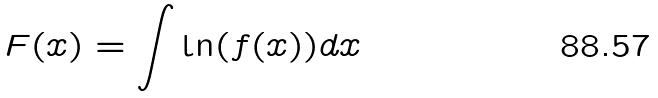Convert formula to latex. <formula><loc_0><loc_0><loc_500><loc_500>F ( x ) = \int \ln ( f ( x ) ) d x</formula> 